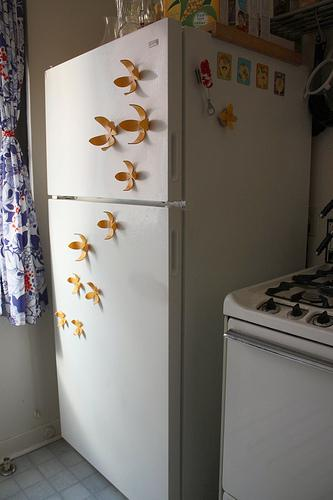Question: when was this photo taken?
Choices:
A. At night.
B. During The day.
C. In the afternoon.
D. In the morning.
Answer with the letter. Answer: B Question: who is the subject of the photo?
Choices:
A. The fridge.
B. The stove.
C. The microwave.
D. The deep freeze.
Answer with the letter. Answer: A 